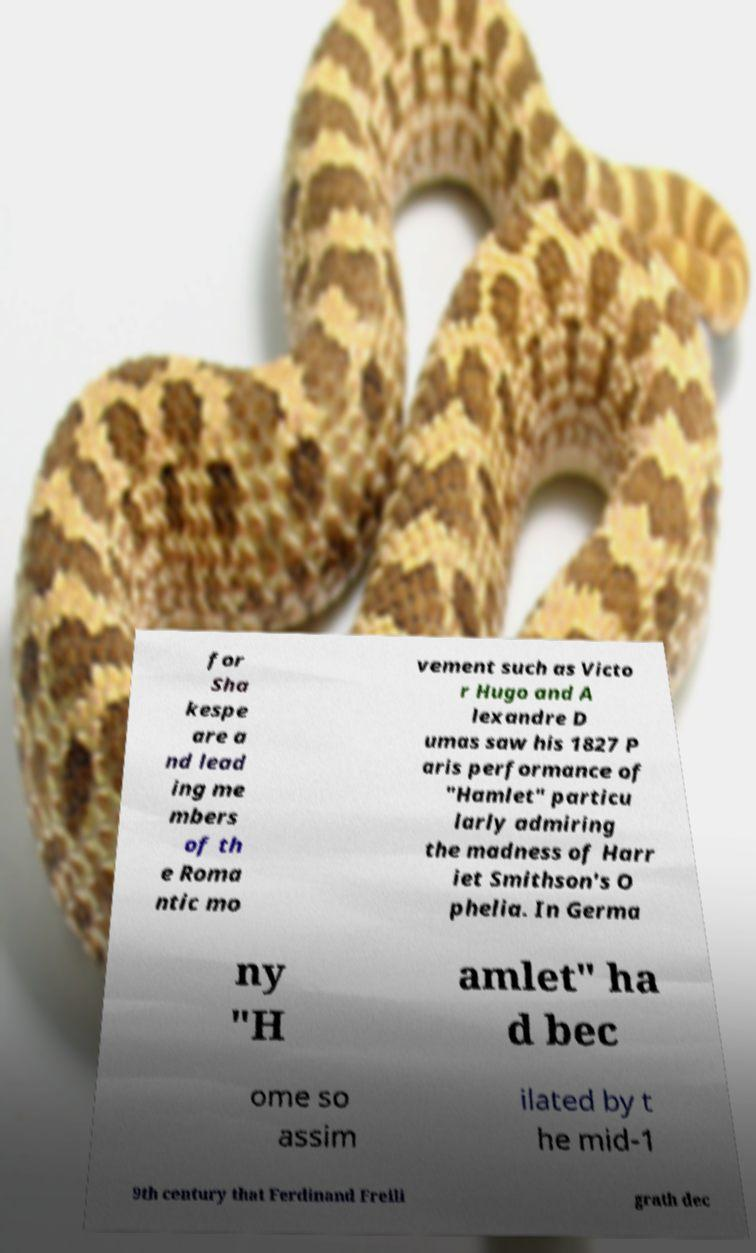Could you assist in decoding the text presented in this image and type it out clearly? for Sha kespe are a nd lead ing me mbers of th e Roma ntic mo vement such as Victo r Hugo and A lexandre D umas saw his 1827 P aris performance of "Hamlet" particu larly admiring the madness of Harr iet Smithson's O phelia. In Germa ny "H amlet" ha d bec ome so assim ilated by t he mid-1 9th century that Ferdinand Freili grath dec 